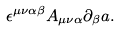Convert formula to latex. <formula><loc_0><loc_0><loc_500><loc_500>\epsilon ^ { \mu \nu \alpha \beta } A _ { \mu \nu \alpha } \partial _ { \beta } a .</formula> 